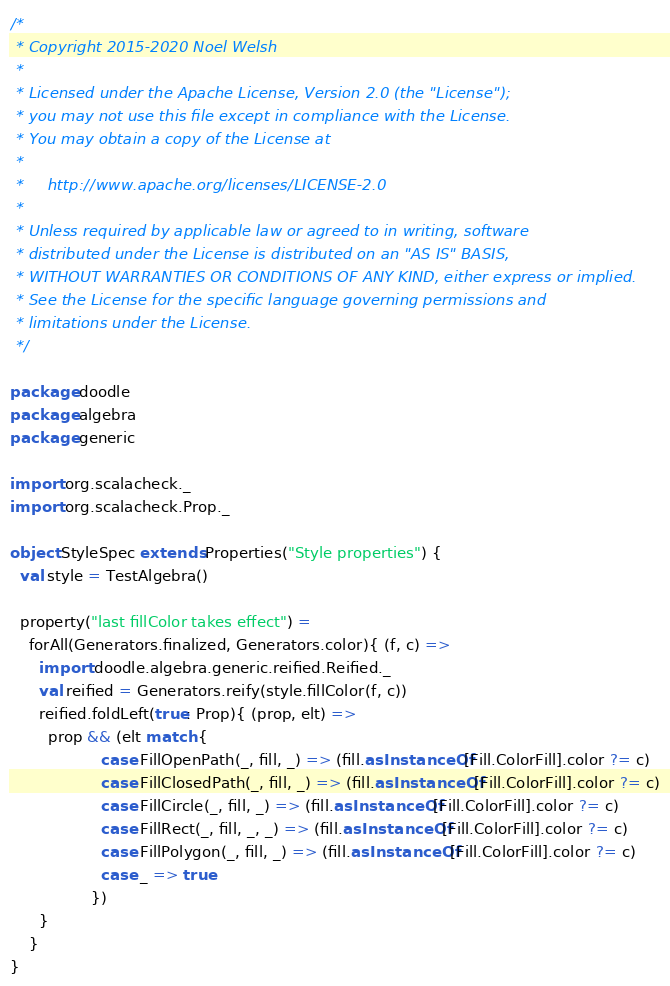Convert code to text. <code><loc_0><loc_0><loc_500><loc_500><_Scala_>/*
 * Copyright 2015-2020 Noel Welsh
 *
 * Licensed under the Apache License, Version 2.0 (the "License");
 * you may not use this file except in compliance with the License.
 * You may obtain a copy of the License at
 *
 *     http://www.apache.org/licenses/LICENSE-2.0
 *
 * Unless required by applicable law or agreed to in writing, software
 * distributed under the License is distributed on an "AS IS" BASIS,
 * WITHOUT WARRANTIES OR CONDITIONS OF ANY KIND, either express or implied.
 * See the License for the specific language governing permissions and
 * limitations under the License.
 */

package doodle
package algebra
package generic

import org.scalacheck._
import org.scalacheck.Prop._

object StyleSpec extends Properties("Style properties") {
  val style = TestAlgebra()

  property("last fillColor takes effect") =
    forAll(Generators.finalized, Generators.color){ (f, c) =>
      import doodle.algebra.generic.reified.Reified._
      val reified = Generators.reify(style.fillColor(f, c))
      reified.foldLeft(true: Prop){ (prop, elt) =>
        prop && (elt match {
                   case FillOpenPath(_, fill, _) => (fill.asInstanceOf[Fill.ColorFill].color ?= c)
                   case FillClosedPath(_, fill, _) => (fill.asInstanceOf[Fill.ColorFill].color ?= c)
                   case FillCircle(_, fill, _) => (fill.asInstanceOf[Fill.ColorFill].color ?= c)
                   case FillRect(_, fill, _, _) => (fill.asInstanceOf[Fill.ColorFill].color ?= c)
                   case FillPolygon(_, fill, _) => (fill.asInstanceOf[Fill.ColorFill].color ?= c)
                   case _ => true
                 })
      }
    }
}
</code> 